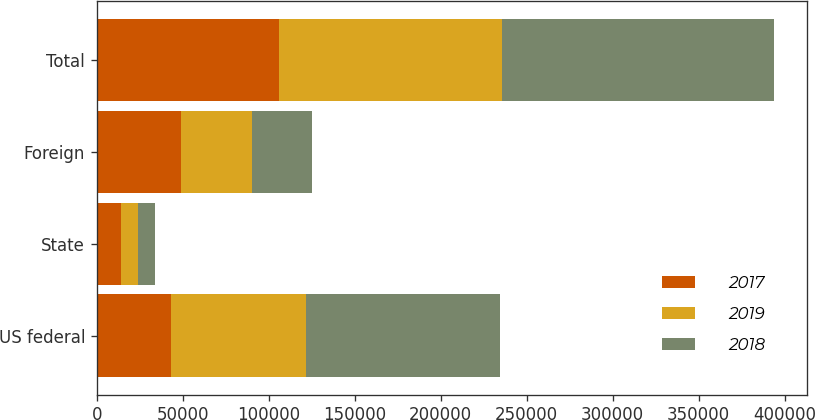Convert chart. <chart><loc_0><loc_0><loc_500><loc_500><stacked_bar_chart><ecel><fcel>US federal<fcel>State<fcel>Foreign<fcel>Total<nl><fcel>2017<fcel>43039<fcel>13864<fcel>49197<fcel>106100<nl><fcel>2019<fcel>78454<fcel>9800<fcel>41040<fcel>129294<nl><fcel>2018<fcel>113105<fcel>10381<fcel>34679<fcel>158165<nl></chart> 